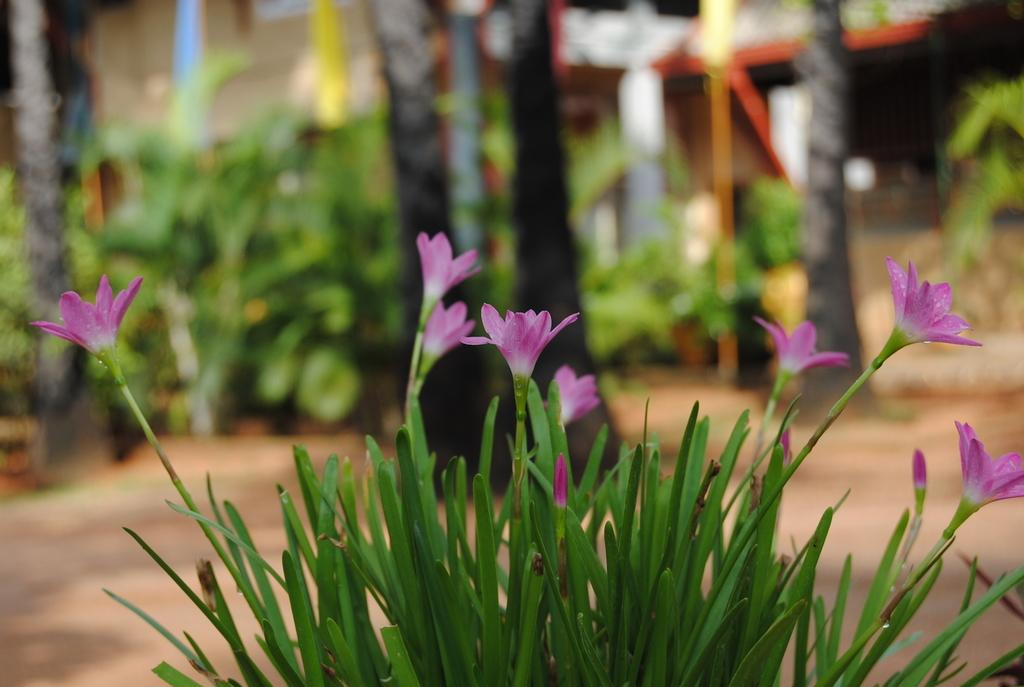What type of living organisms can be seen in the image? Plants can be seen in the image. What specific feature of the plants is visible? The plants have flowers. What can be seen in the distance behind the plants? There are trees in the background of the image. How is the background of the image depicted? The background is blurred. Is there a squirrel climbing the ship during the holiday in the image? There is no squirrel, ship, or holiday depicted in the image; it features plants with flowers and a blurred background of trees. 